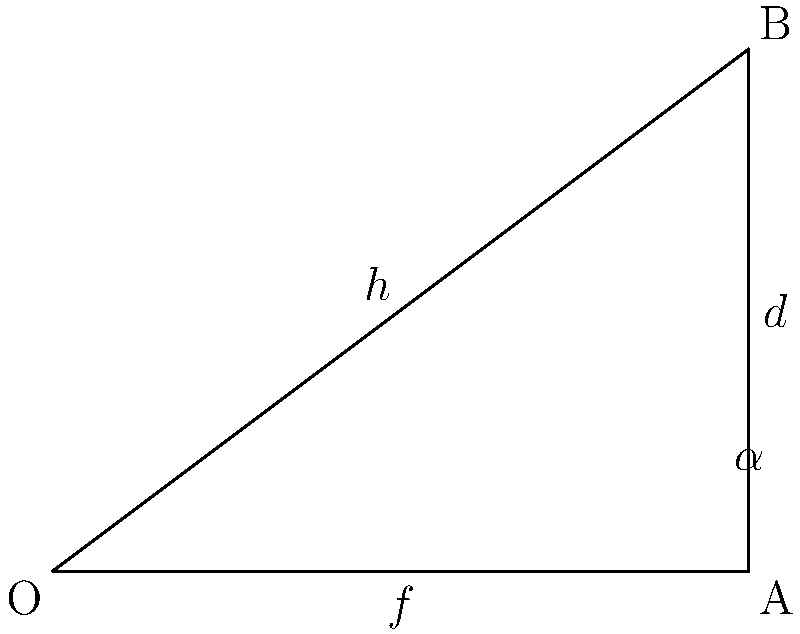As a freelance photographer, you're using a camera with a 50mm lens to capture a distant subject. The angle of view ($\alpha$) of your lens is 40°. If you want to determine the distance ($d$) to your subject, which appears to be 3 meters tall in the frame, how far away is it? Round your answer to the nearest meter. Let's approach this step-by-step:

1) In a camera, the relationship between the focal length ($f$), the height of the subject in reality ($h$), the distance to the subject ($d$), and the height of the sensor ($y$) is given by:

   $$\frac{h}{d} = \frac{y}{f}$$

2) We don't know $y$, but we can find it using the angle of view ($\alpha$) and the focal length ($f$):

   $$\tan(\frac{\alpha}{2}) = \frac{y/2}{f}$$

3) Rearranging this equation:

   $$y = 2f \tan(\frac{\alpha}{2})$$

4) Now, let's plug in our known values:
   $f = 50\text{ mm} = 0.05\text{ m}$
   $\alpha = 40°$

   $$y = 2 \cdot 0.05 \cdot \tan(20°) = 0.0364\text{ m}$$

5) Now we can use the first equation:

   $$\frac{h}{d} = \frac{0.0364}{0.05}$$

6) We know $h = 3\text{ m}$, so:

   $$\frac{3}{d} = \frac{0.0364}{0.05}$$

7) Solving for $d$:

   $$d = \frac{3 \cdot 0.05}{0.0364} = 4.12\text{ m}$$

8) Rounding to the nearest meter:

   $$d \approx 4\text{ m}$$
Answer: 4 meters 